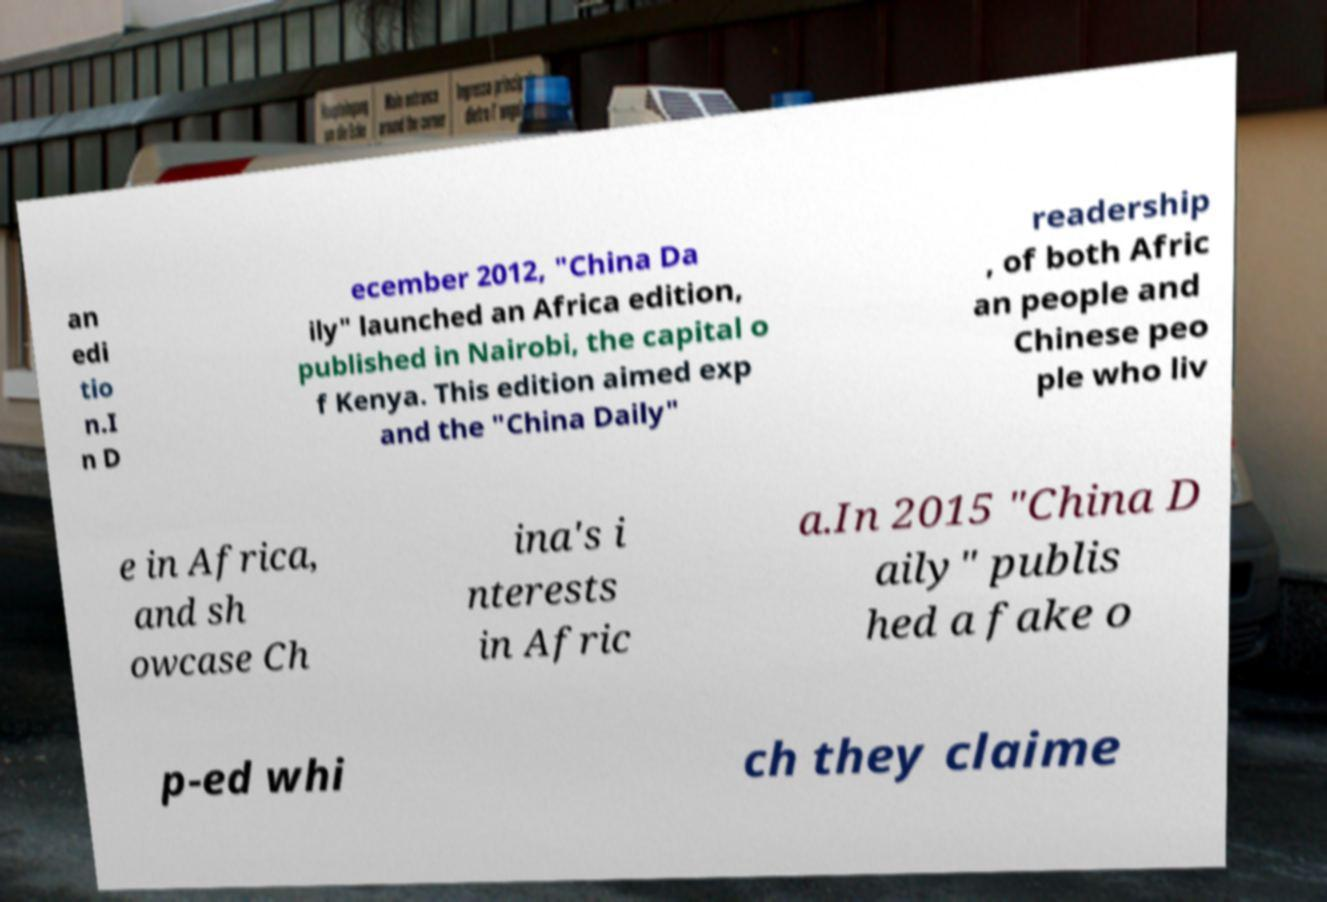Please read and relay the text visible in this image. What does it say? an edi tio n.I n D ecember 2012, "China Da ily" launched an Africa edition, published in Nairobi, the capital o f Kenya. This edition aimed exp and the "China Daily" readership , of both Afric an people and Chinese peo ple who liv e in Africa, and sh owcase Ch ina's i nterests in Afric a.In 2015 "China D aily" publis hed a fake o p-ed whi ch they claime 